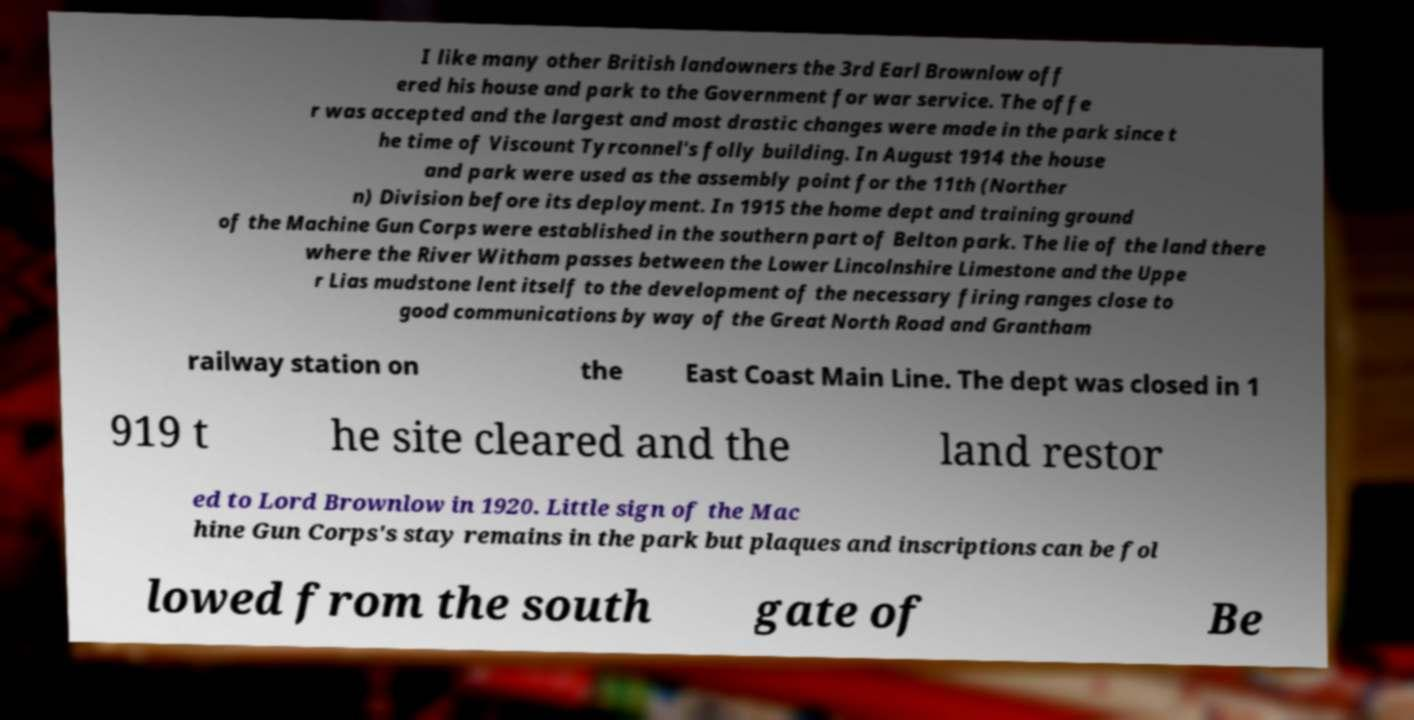For documentation purposes, I need the text within this image transcribed. Could you provide that? I like many other British landowners the 3rd Earl Brownlow off ered his house and park to the Government for war service. The offe r was accepted and the largest and most drastic changes were made in the park since t he time of Viscount Tyrconnel's folly building. In August 1914 the house and park were used as the assembly point for the 11th (Norther n) Division before its deployment. In 1915 the home dept and training ground of the Machine Gun Corps were established in the southern part of Belton park. The lie of the land there where the River Witham passes between the Lower Lincolnshire Limestone and the Uppe r Lias mudstone lent itself to the development of the necessary firing ranges close to good communications by way of the Great North Road and Grantham railway station on the East Coast Main Line. The dept was closed in 1 919 t he site cleared and the land restor ed to Lord Brownlow in 1920. Little sign of the Mac hine Gun Corps's stay remains in the park but plaques and inscriptions can be fol lowed from the south gate of Be 